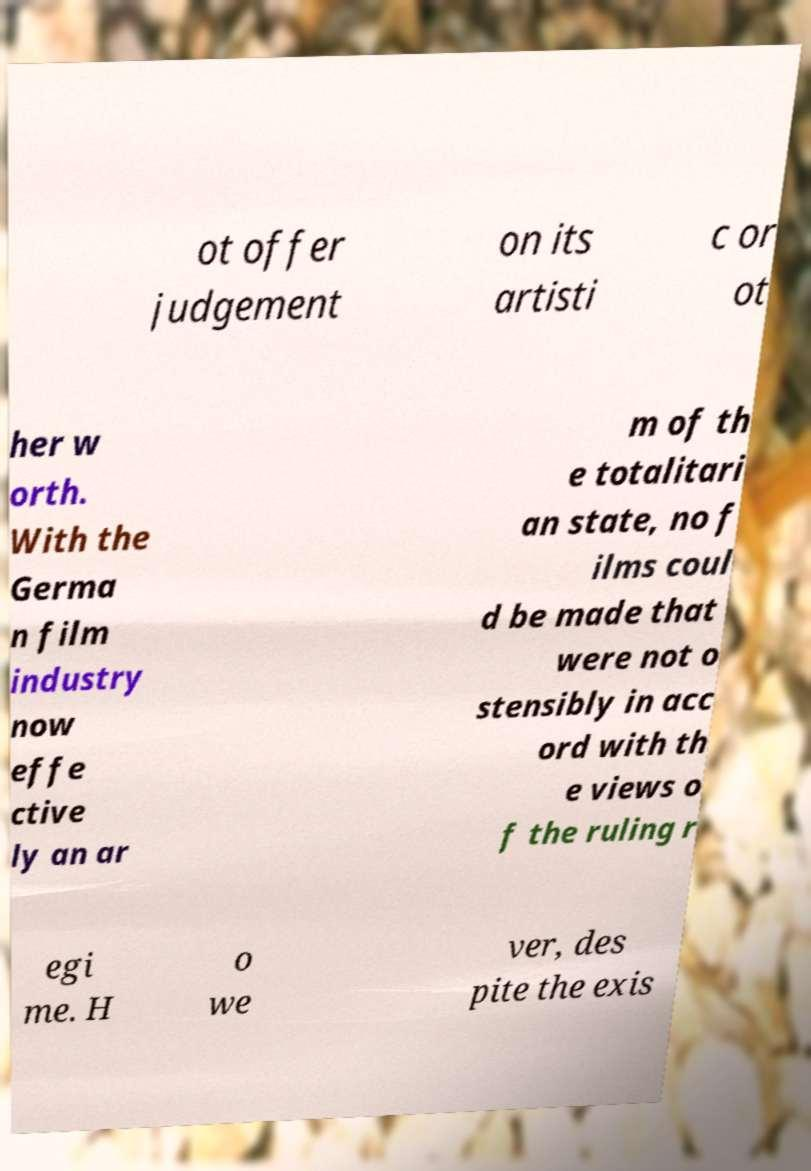There's text embedded in this image that I need extracted. Can you transcribe it verbatim? ot offer judgement on its artisti c or ot her w orth. With the Germa n film industry now effe ctive ly an ar m of th e totalitari an state, no f ilms coul d be made that were not o stensibly in acc ord with th e views o f the ruling r egi me. H o we ver, des pite the exis 